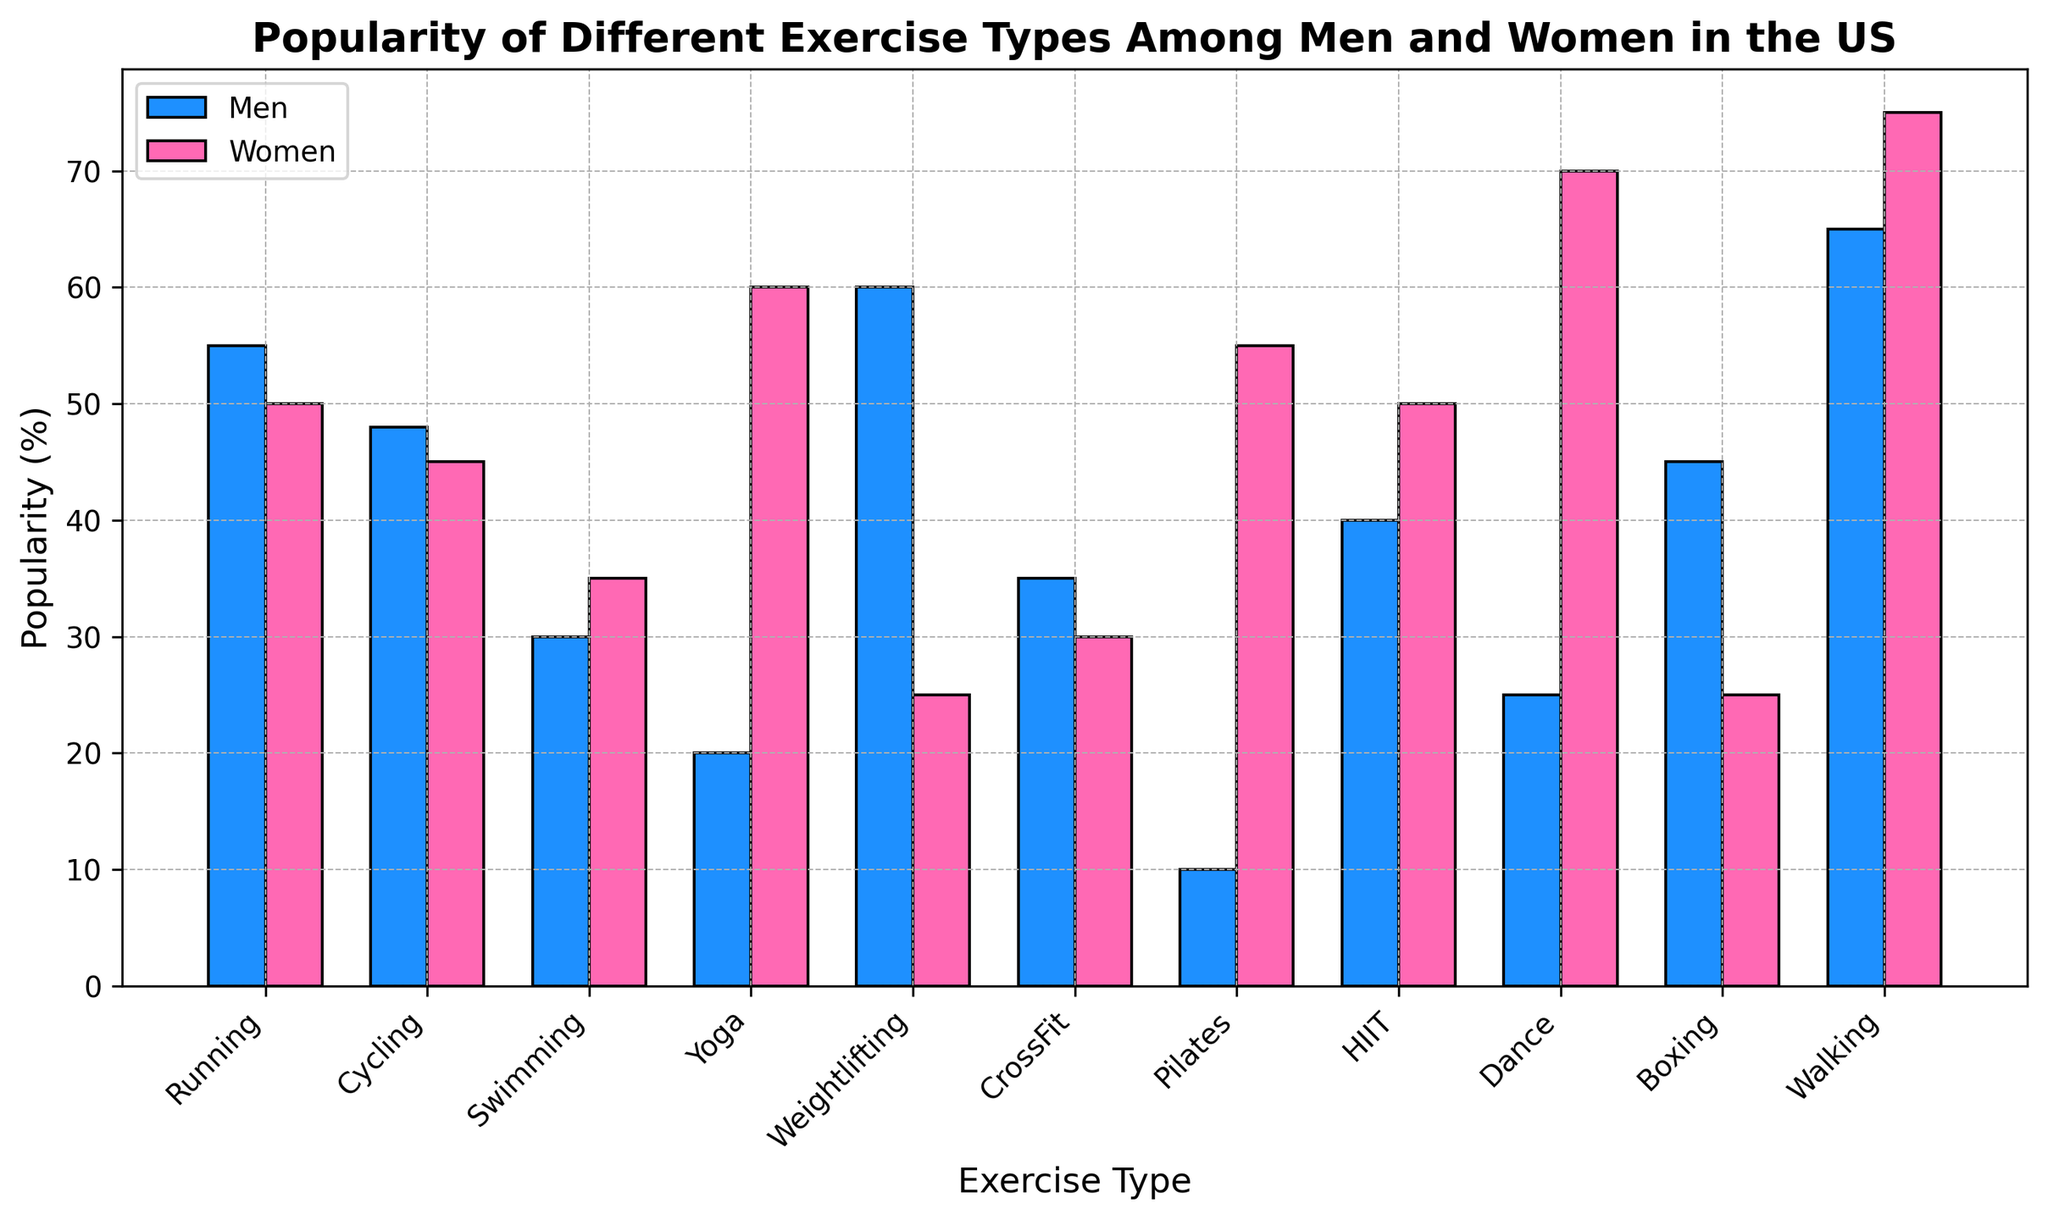Do men prefer Yoga or Pilates? Men's popularity percentage for Yoga is 20%, and for Pilates is 10%. Since 20% (Yoga) is greater than 10% (Pilates), men prefer Yoga more.
Answer: Yoga Which exercise type is equally popular among men and women? Boxing is equally popular among men and women with both having a popularity percentage of 25%.
Answer: Boxing What is the sum of percentages for Weightlifting among both genders? Weightlifting percentage for men is 60%, and for women is 25%. Adding these together gives 60 + 25 = 85%.
Answer: 85% Which exercise type shows the greatest variation in popularity between men and women? Yoga shows the greatest variation, with 60% popularity among women and 20% among men, yielding a difference of 60 - 20 = 40%.
Answer: Yoga Do more men prefer Running or HIIT? Comparing percentages, Running has 55% for men, and HIIT has 40%. Since 55% is greater than 40%, more men prefer Running.
Answer: Running Which exercise type do women prefer the most? The exercise type with the highest popularity percentage among women is Dance with 70%.
Answer: Dance What is the average popularity percentage of Boxing and Cycling among men? The popularity percentages for Boxing and Cycling among men are 45% and 48%, respectively. The average is calculated as (45 + 48) / 2 = 46.5%.
Answer: 46.5% Among the listed exercise types, which one is the least popular among men? The least popular exercise type among men is Pilates with a popularity percentage of 10%.
Answer: Pilates 